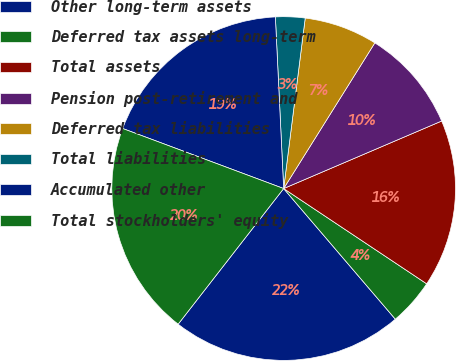Convert chart to OTSL. <chart><loc_0><loc_0><loc_500><loc_500><pie_chart><fcel>Other long-term assets<fcel>Deferred tax assets long-term<fcel>Total assets<fcel>Pension post-retirement and<fcel>Deferred tax liabilities<fcel>Total liabilities<fcel>Accumulated other<fcel>Total stockholders' equity<nl><fcel>21.78%<fcel>4.39%<fcel>15.78%<fcel>9.67%<fcel>6.9%<fcel>2.77%<fcel>18.55%<fcel>20.16%<nl></chart> 